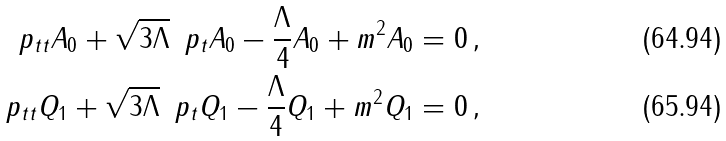Convert formula to latex. <formula><loc_0><loc_0><loc_500><loc_500>\ p _ { t t } A _ { 0 } + \sqrt { 3 \Lambda } \, \ p _ { t } A _ { 0 } - \frac { \Lambda } { 4 } A _ { 0 } + m ^ { 2 } A _ { 0 } = 0 \, , \\ \ p _ { t t } Q _ { 1 } + \sqrt { 3 \Lambda } \, \ p _ { t } Q _ { 1 } - \frac { \Lambda } { 4 } Q _ { 1 } + m ^ { 2 } Q _ { 1 } = 0 \, ,</formula> 